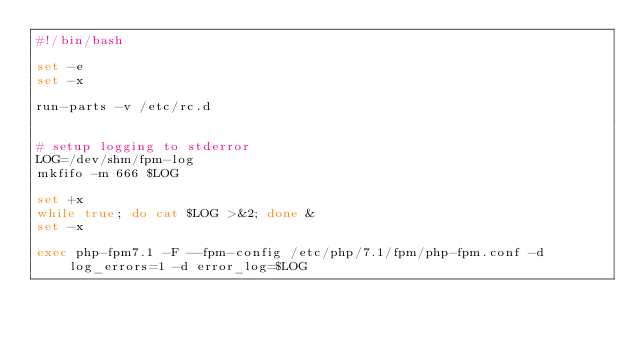Convert code to text. <code><loc_0><loc_0><loc_500><loc_500><_Bash_>#!/bin/bash

set -e
set -x

run-parts -v /etc/rc.d


# setup logging to stderror
LOG=/dev/shm/fpm-log
mkfifo -m 666 $LOG

set +x
while true; do cat $LOG >&2; done &
set -x

exec php-fpm7.1 -F --fpm-config /etc/php/7.1/fpm/php-fpm.conf -d log_errors=1 -d error_log=$LOG

</code> 